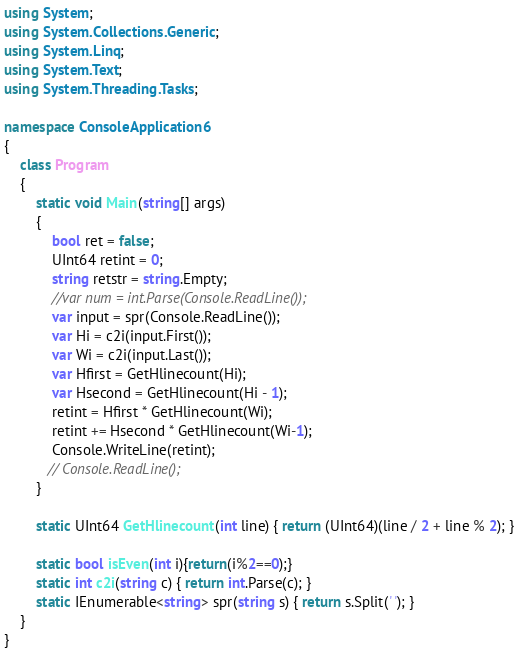<code> <loc_0><loc_0><loc_500><loc_500><_C#_>using System;
using System.Collections.Generic;
using System.Linq;
using System.Text;
using System.Threading.Tasks;

namespace ConsoleApplication6
{
    class Program
    {
        static void Main(string[] args)
        {
            bool ret = false;
            UInt64 retint = 0;
            string retstr = string.Empty;
            //var num = int.Parse(Console.ReadLine());
            var input = spr(Console.ReadLine());
            var Hi = c2i(input.First());
            var Wi = c2i(input.Last());
            var Hfirst = GetHlinecount(Hi);
            var Hsecond = GetHlinecount(Hi - 1);
            retint = Hfirst * GetHlinecount(Wi);
            retint += Hsecond * GetHlinecount(Wi-1);
            Console.WriteLine(retint);
           // Console.ReadLine();
        }

        static UInt64 GetHlinecount(int line) { return (UInt64)(line / 2 + line % 2); }

        static bool isEven(int i){return(i%2==0);}    
        static int c2i(string c) { return int.Parse(c); }
        static IEnumerable<string> spr(string s) { return s.Split(' '); }
    }
}
</code> 